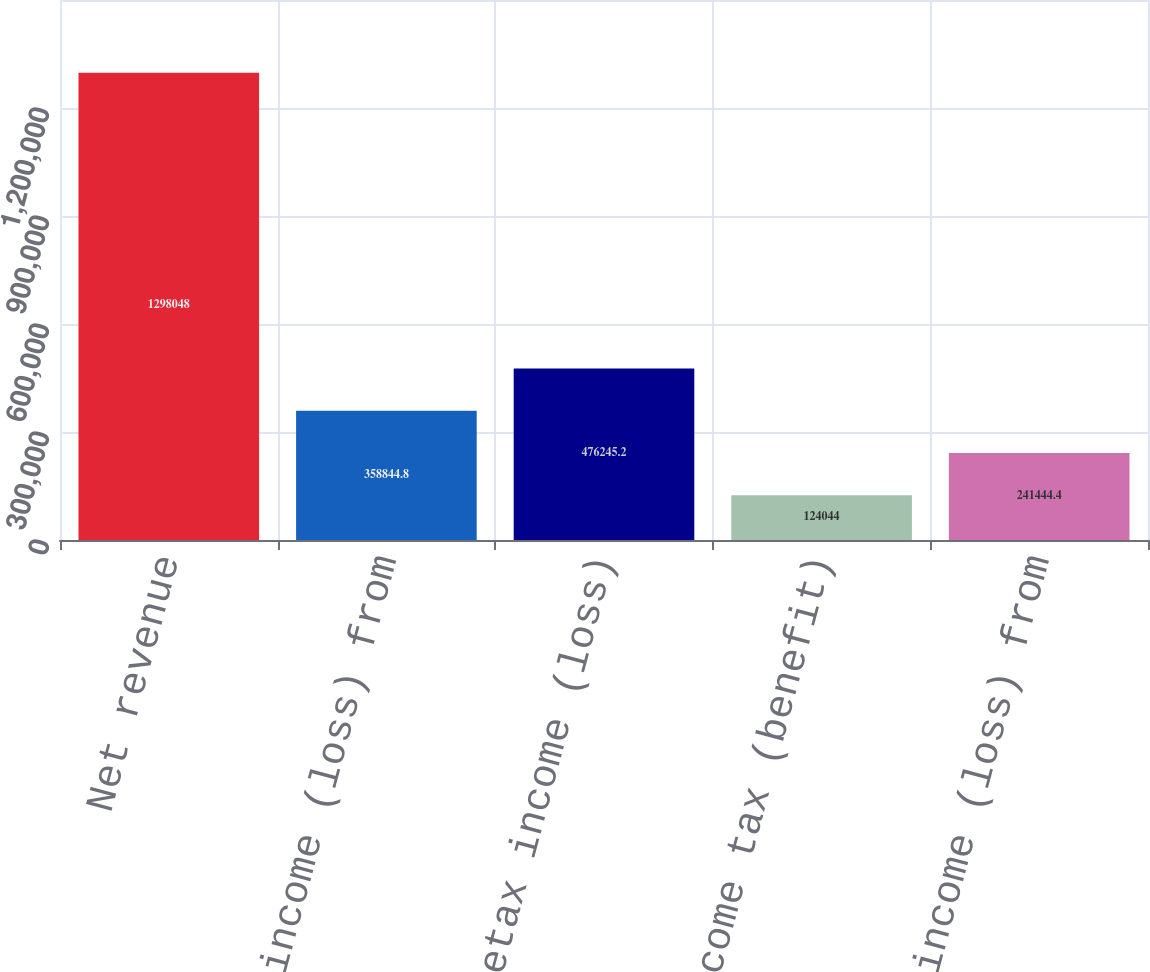<chart> <loc_0><loc_0><loc_500><loc_500><bar_chart><fcel>Net revenue<fcel>Pretax income (loss) from<fcel>Pretax income (loss)<fcel>Income tax (benefit)<fcel>Net income (loss) from<nl><fcel>1.29805e+06<fcel>358845<fcel>476245<fcel>124044<fcel>241444<nl></chart> 